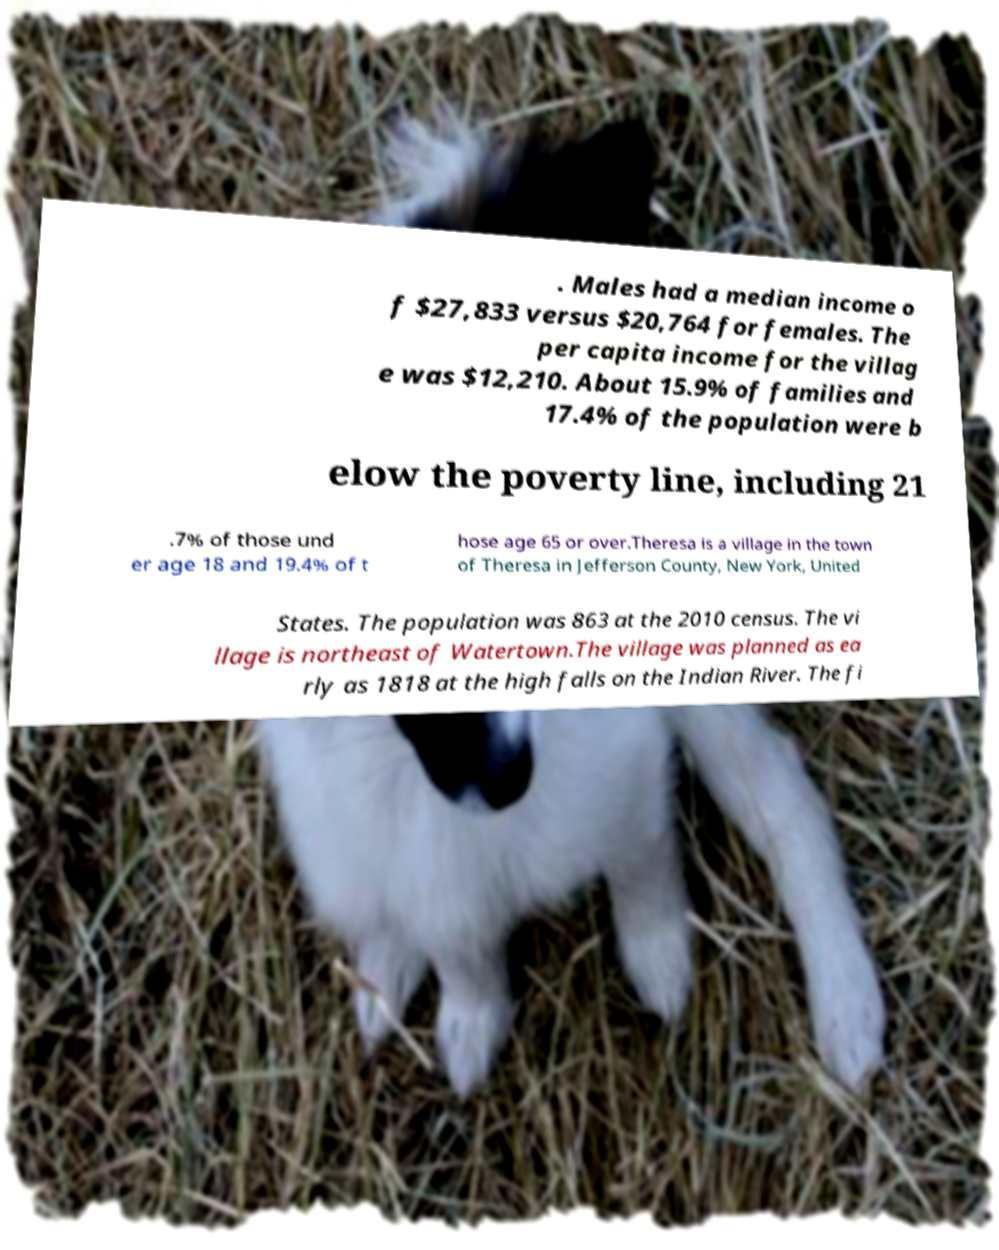There's text embedded in this image that I need extracted. Can you transcribe it verbatim? . Males had a median income o f $27,833 versus $20,764 for females. The per capita income for the villag e was $12,210. About 15.9% of families and 17.4% of the population were b elow the poverty line, including 21 .7% of those und er age 18 and 19.4% of t hose age 65 or over.Theresa is a village in the town of Theresa in Jefferson County, New York, United States. The population was 863 at the 2010 census. The vi llage is northeast of Watertown.The village was planned as ea rly as 1818 at the high falls on the Indian River. The fi 